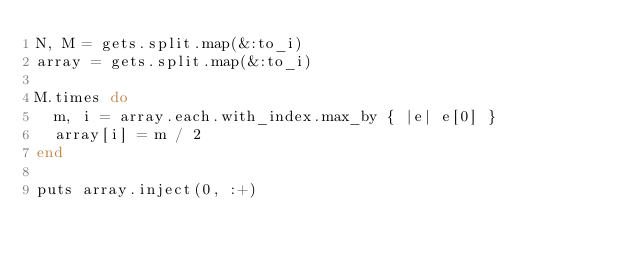Convert code to text. <code><loc_0><loc_0><loc_500><loc_500><_Ruby_>N, M = gets.split.map(&:to_i)
array = gets.split.map(&:to_i)

M.times do
  m, i = array.each.with_index.max_by { |e| e[0] }
  array[i] = m / 2
end

puts array.inject(0, :+)
</code> 